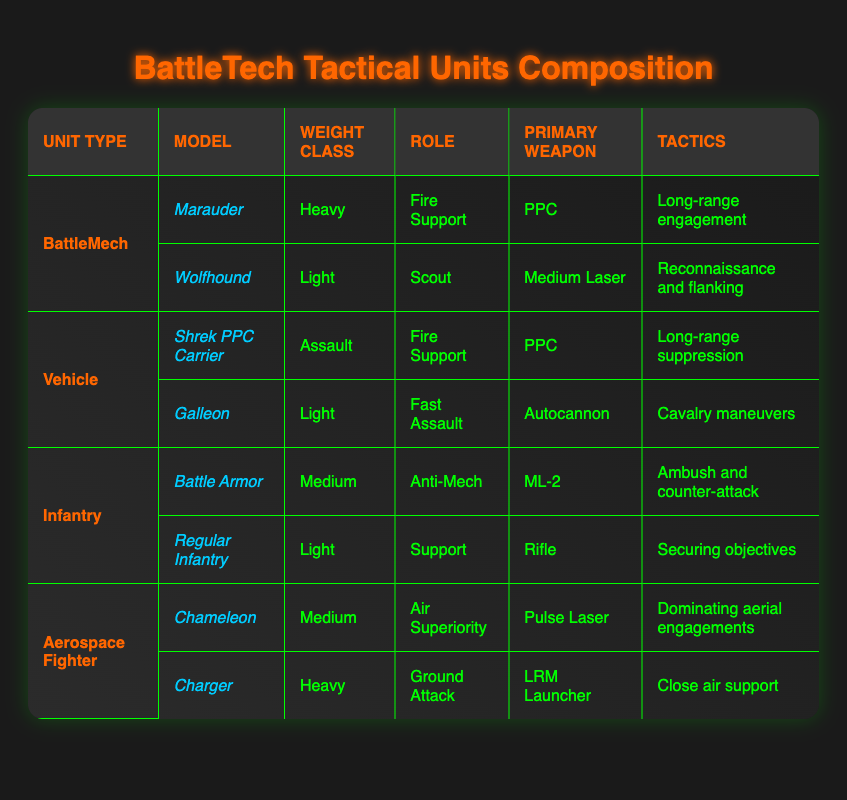What are the primary weapons of the BattleMech unit types? The table lists two BattleMech models: the Marauder and the Wolfhound. The primary weapon of the Marauder is a PPC, while the Wolfhound uses a Medium Laser.
Answer: PPC, Medium Laser Which unit has the role of "Anti-Mech"? From the Infantry section of the table, the model that serves as "Anti-Mech" is the Battle Armor.
Answer: Battle Armor What is the weight class of the Galleon? In the Vehicle section, the Galleon is listed as a Light weight class unit.
Answer: Light Is the Shrek PPC Carrier designed for close support? The Shrek PPC Carrier has a role identified as "Fire Support" and uses tactics for long-range suppression, indicating it is not designed for close support.
Answer: No What is the total number of units listed for the Vehicle category? There are two vehicle models listed: the Shrek PPC Carrier and the Galleon. Thus, the total count for this category is 2.
Answer: 2 Which unit is designated for "Air Superiority" and what is its primary weapon? The Chameleon, listed under the Aerospace Fighter category, has the role of Air Superiority and uses a Pulse Laser as its primary weapon.
Answer: Chameleon, Pulse Laser What are the tactics employed by the Battle Armor? The tactics for Battle Armor, found in the Infantry section, is "Ambush and counter-attack."
Answer: Ambush and counter-attack Does the Charger unit fall under the Heavy weight class? According to the table in the Aerospace Fighter section, the Charger is categorized as Heavy.
Answer: Yes What is the predominant weight class in the BattleMech category? The weight class of Marauder is Heavy, while the Wolfhound is Light, so there are units in both Heavy and Light classes. The predominant weight class is not definitive, as both are included.
Answer: Not definitive (Heavy, Light) What role does the Regular Infantry serve? The Regular Infantry is identified as having the role of "Support" in the Infantry section of the table.
Answer: Support 